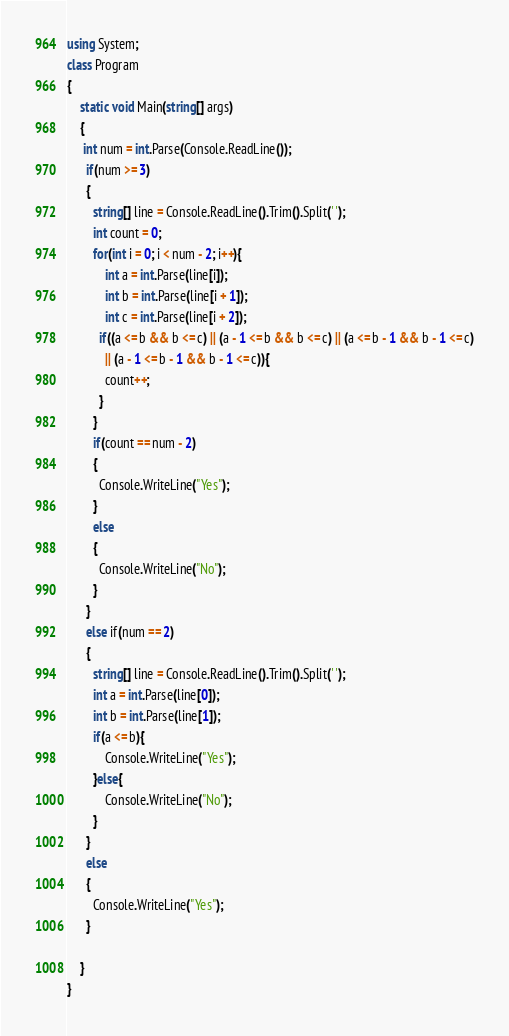<code> <loc_0><loc_0><loc_500><loc_500><_C#_>using System;
class Program
{
	static void Main(string[] args)
    {
     int num = int.Parse(Console.ReadLine());
      if(num >= 3)
      {
        string[] line = Console.ReadLine().Trim().Split(' ');
        int count = 0;
        for(int i = 0; i < num - 2; i++){
        	int a = int.Parse(line[i]);
        	int b = int.Parse(line[i + 1]);
         	int c = int.Parse(line[i + 2]);
          if((a <= b && b <= c) || (a - 1 <= b && b <= c) || (a <= b - 1 && b - 1 <= c)
            || (a - 1 <= b - 1 && b - 1 <= c)){
            count++;
          }
        }
      	if(count == num - 2)
        {
          Console.WriteLine("Yes");
        }
        else
        {
          Console.WriteLine("No");
        }
      }
      else if(num == 2)
      {
        string[] line = Console.ReadLine().Trim().Split(' ');
        int a = int.Parse(line[0]);
        int b = int.Parse(line[1]);
        if(a <= b){
        	Console.WriteLine("Yes");
      	}else{
			Console.WriteLine("No");
      	}
      }
      else
      {
        Console.WriteLine("Yes");
      }
      
    }
}
</code> 